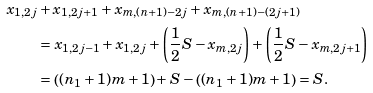Convert formula to latex. <formula><loc_0><loc_0><loc_500><loc_500>x _ { 1 , 2 j } & + x _ { 1 , 2 j + 1 } + x _ { m , ( n + 1 ) - 2 j } + x _ { m , ( n + 1 ) - ( 2 j + 1 ) } \\ & = x _ { 1 , 2 j - 1 } + x _ { 1 , 2 j } + \left ( \frac { 1 } { 2 } S - x _ { m , 2 j } \right ) + \left ( \frac { 1 } { 2 } S - x _ { m , 2 j + 1 } \right ) \\ & = \left ( ( n _ { 1 } + 1 ) m + 1 \right ) + S - \left ( ( n _ { 1 } + 1 ) m + 1 \right ) = S .</formula> 